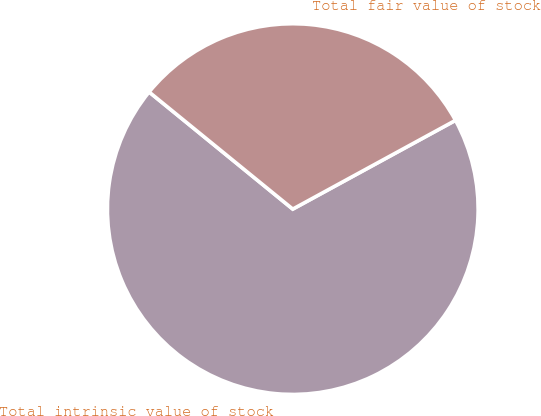Convert chart. <chart><loc_0><loc_0><loc_500><loc_500><pie_chart><fcel>Total intrinsic value of stock<fcel>Total fair value of stock<nl><fcel>68.83%<fcel>31.17%<nl></chart> 